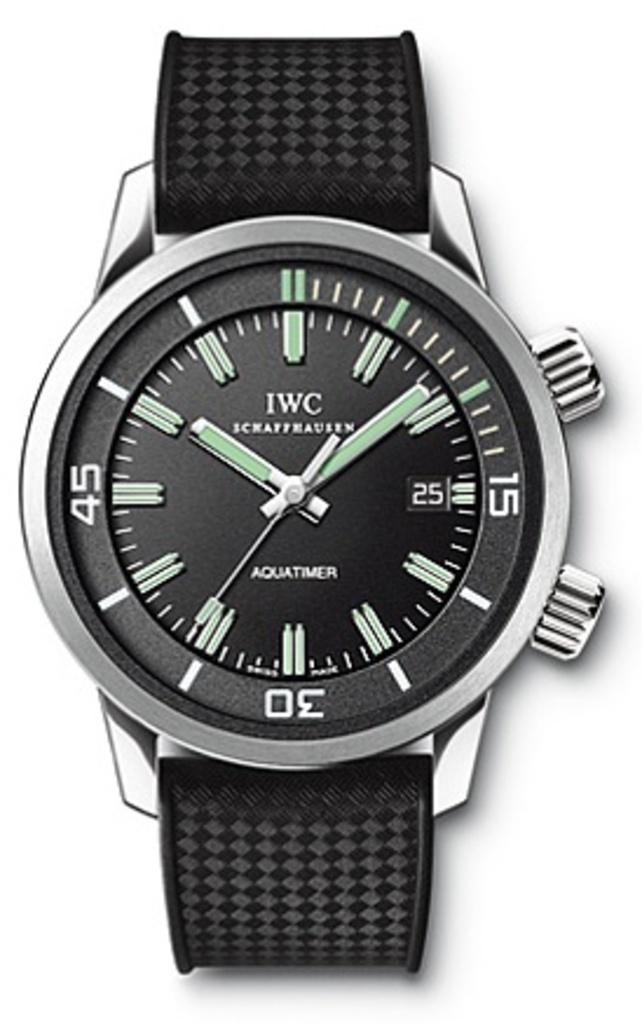<image>
Give a short and clear explanation of the subsequent image. A black watch displays the time of 10:09. 